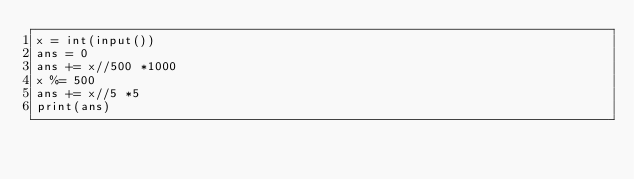Convert code to text. <code><loc_0><loc_0><loc_500><loc_500><_Python_>x = int(input())
ans = 0
ans += x//500 *1000
x %= 500
ans += x//5 *5
print(ans)</code> 